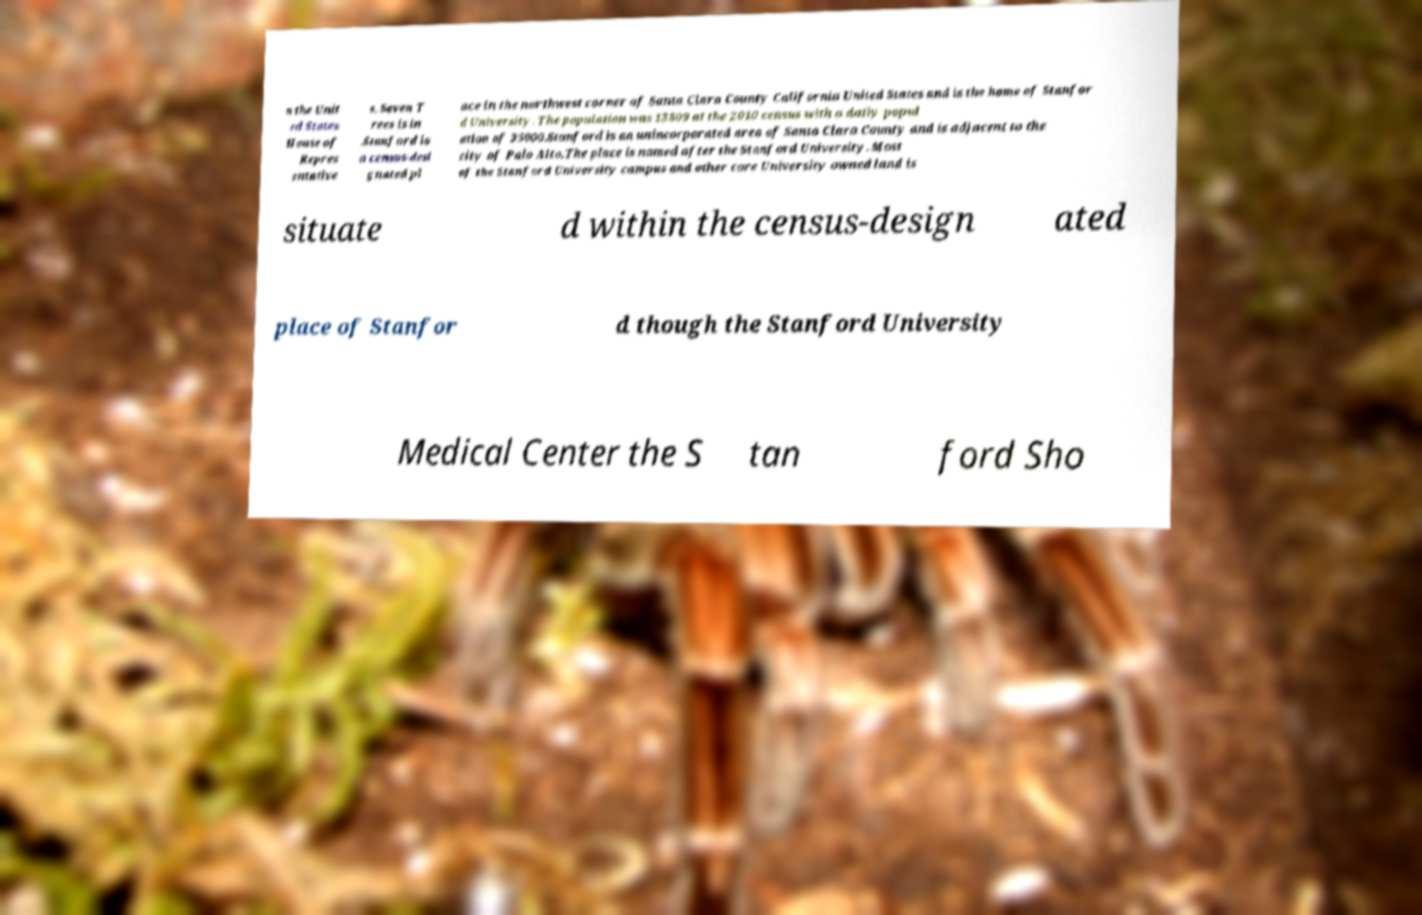I need the written content from this picture converted into text. Can you do that? n the Unit ed States House of Repres entative s, Seven T rees is in .Stanford is a census-desi gnated pl ace in the northwest corner of Santa Clara County California United States and is the home of Stanfor d University. The population was 13809 at the 2010 census with a daily popul ation of 35000.Stanford is an unincorporated area of Santa Clara County and is adjacent to the city of Palo Alto.The place is named after the Stanford University. Most of the Stanford University campus and other core University owned land is situate d within the census-design ated place of Stanfor d though the Stanford University Medical Center the S tan ford Sho 